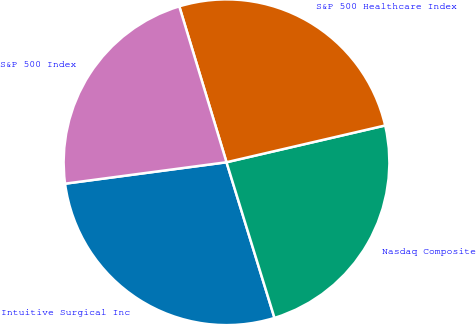Convert chart to OTSL. <chart><loc_0><loc_0><loc_500><loc_500><pie_chart><fcel>Intuitive Surgical Inc<fcel>Nasdaq Composite<fcel>S&P 500 Healthcare Index<fcel>S&P 500 Index<nl><fcel>27.66%<fcel>23.87%<fcel>26.06%<fcel>22.42%<nl></chart> 